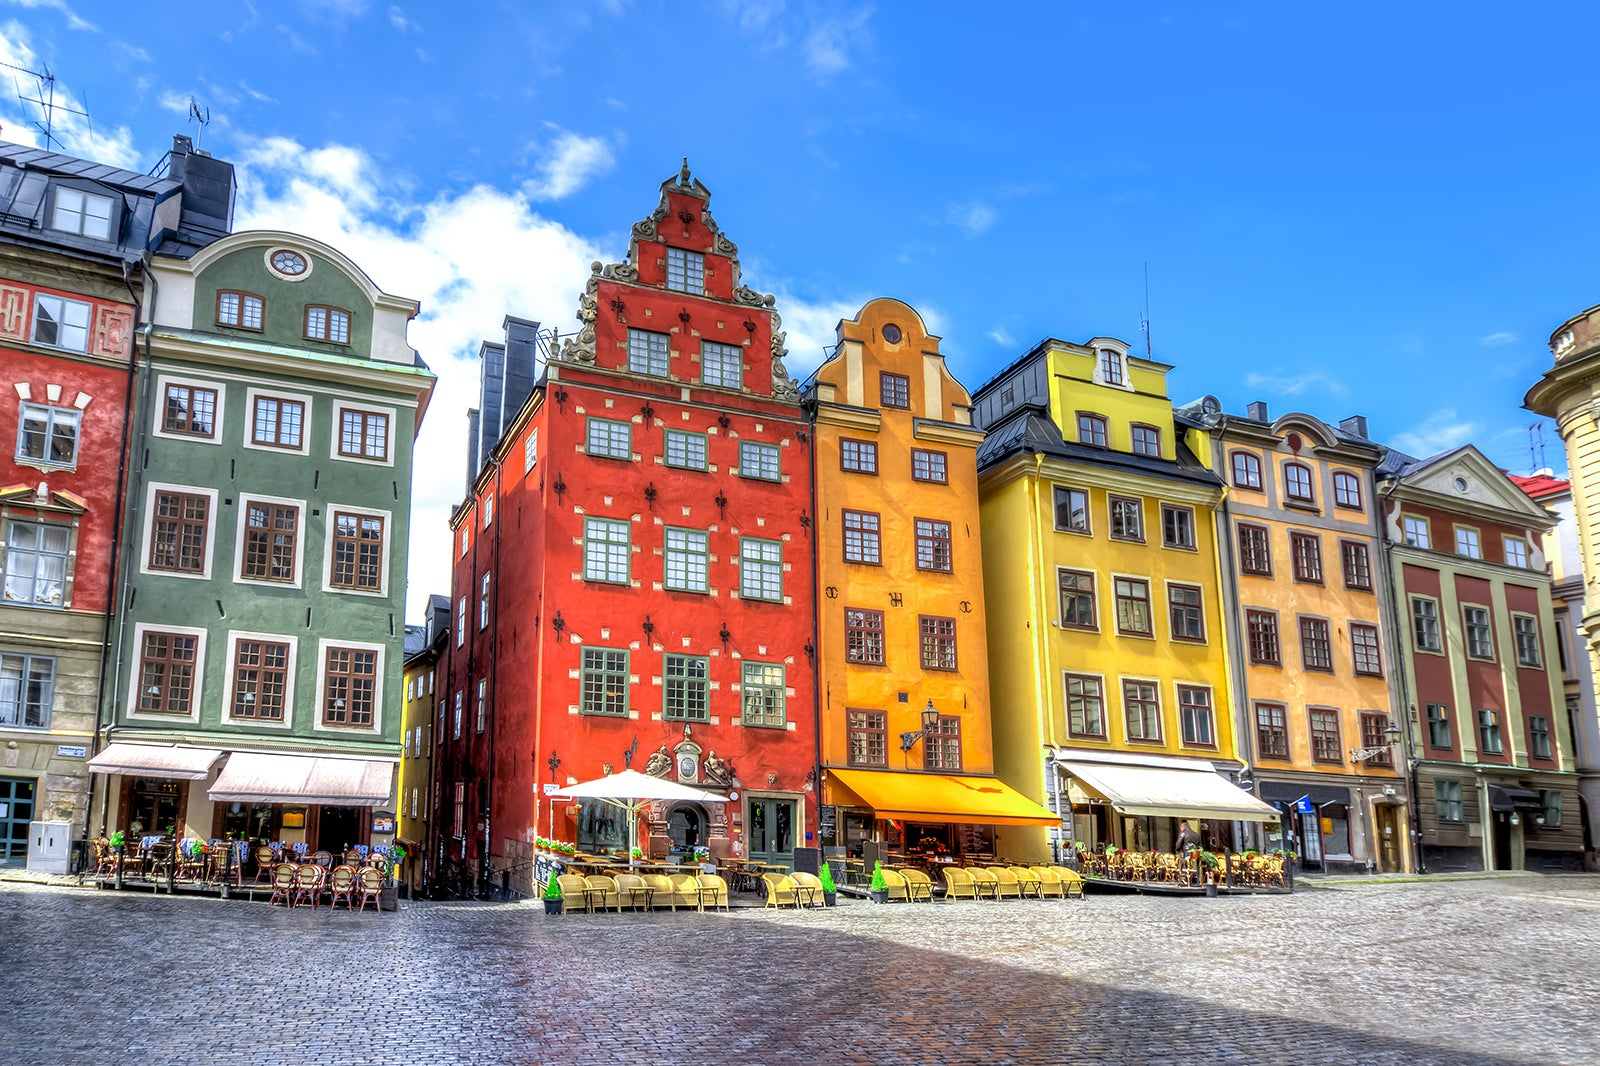Could you describe the historical significance of the red building in the image? Certainly! The striking red building is the iconic Chokladkoppen, located in Stortorget, the oldest square in Stockholm. Dating back to the 17th century, this building, like many others in Gamla Stan, is a fine example of North German architecture. It has a storied past, once serving as a meeting point for merchants and later, as a popular café. Its vivid color and ornate decorations make it a distinct landmark and a favorite subject for photographers. 